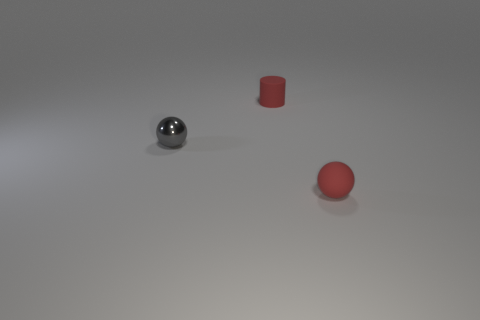What color is the small metal object?
Your answer should be compact. Gray. There is a tiny matte object in front of the tiny gray object; is it the same color as the small matte cylinder?
Make the answer very short. Yes. There is a small rubber object that is the same shape as the tiny shiny object; what color is it?
Your answer should be very brief. Red. How many large things are either purple metal balls or shiny objects?
Ensure brevity in your answer.  0. There is a object on the left side of the small matte cylinder; how big is it?
Your response must be concise. Small. Is there a small metallic sphere that has the same color as the small rubber cylinder?
Your answer should be very brief. No. Do the tiny cylinder and the metallic object have the same color?
Your answer should be very brief. No. There is a tiny rubber object that is the same color as the matte ball; what is its shape?
Provide a short and direct response. Cylinder. There is a tiny red object that is in front of the gray shiny ball; what number of matte objects are behind it?
Offer a terse response. 1. What number of gray objects are the same material as the gray ball?
Make the answer very short. 0. 